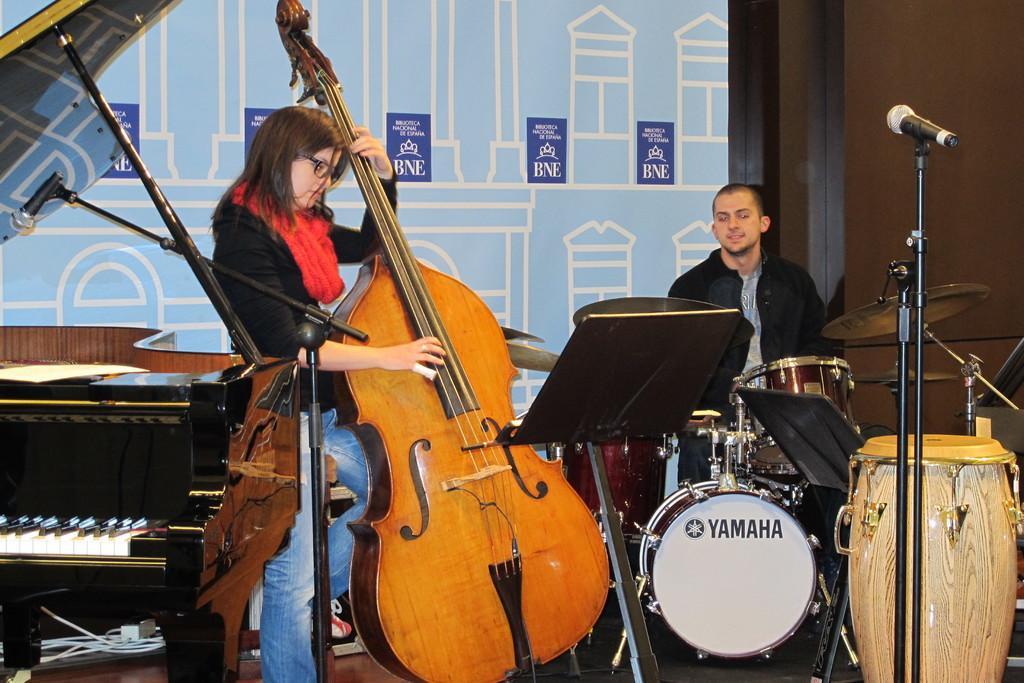Could you give a brief overview of what you see in this image? Here we can see a woman is standing and playing guitar, and at side a person is sitting and playing drums, and here is the piano. 